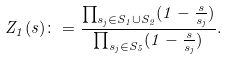Convert formula to latex. <formula><loc_0><loc_0><loc_500><loc_500>Z _ { 1 } ( s ) \colon = \frac { \prod _ { s _ { j } \in S _ { 1 } \cup S _ { 2 } } ( 1 - \frac { s } { s _ { j } } ) } { \prod _ { s _ { j } \in S _ { 5 } } ( 1 - \frac { s } { s _ { j } } ) } .</formula> 